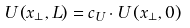<formula> <loc_0><loc_0><loc_500><loc_500>U \left ( x _ { \perp } , L \right ) = c _ { U } \cdot U \left ( x _ { \perp } , 0 \right )</formula> 